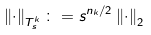Convert formula to latex. <formula><loc_0><loc_0><loc_500><loc_500>\left \| \cdot \right \| _ { T _ { s } ^ { k } } \colon = s ^ { n _ { k } / 2 } \left \| \cdot \right \| _ { 2 }</formula> 